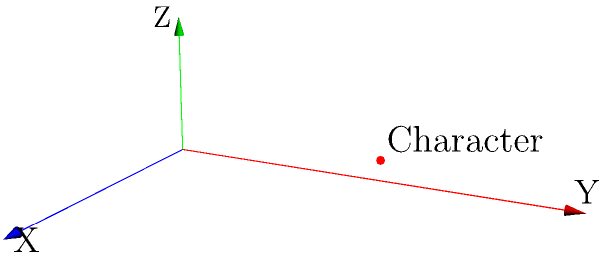In an Unreal Engine 4 game, a character is positioned at coordinates (1, 2, 0.5) in the game world. The character needs to move 3 units forward along the X-axis, 1 unit to the right along the Y-axis, and 0.5 units up along the Z-axis. What will be the character's new position vector after this movement? To solve this problem, we need to follow these steps:

1. Identify the initial position vector:
   Initial position = $\vec{v_i} = (1, 2, 0.5)$

2. Identify the movement vector:
   Movement = $\vec{m} = (3, 1, 0.5)$
   - 3 units forward along X-axis
   - 1 unit to the right along Y-axis
   - 0.5 units up along Z-axis

3. Calculate the new position vector by adding the initial position vector and the movement vector:
   $\vec{v_f} = \vec{v_i} + \vec{m}$

4. Perform the vector addition:
   $\vec{v_f} = (1, 2, 0.5) + (3, 1, 0.5)$

5. Add the corresponding components:
   $\vec{v_f} = (1+3, 2+1, 0.5+0.5)$

6. Simplify:
   $\vec{v_f} = (4, 3, 1)$

Therefore, the character's new position vector after the movement will be (4, 3, 1).
Answer: $(4, 3, 1)$ 